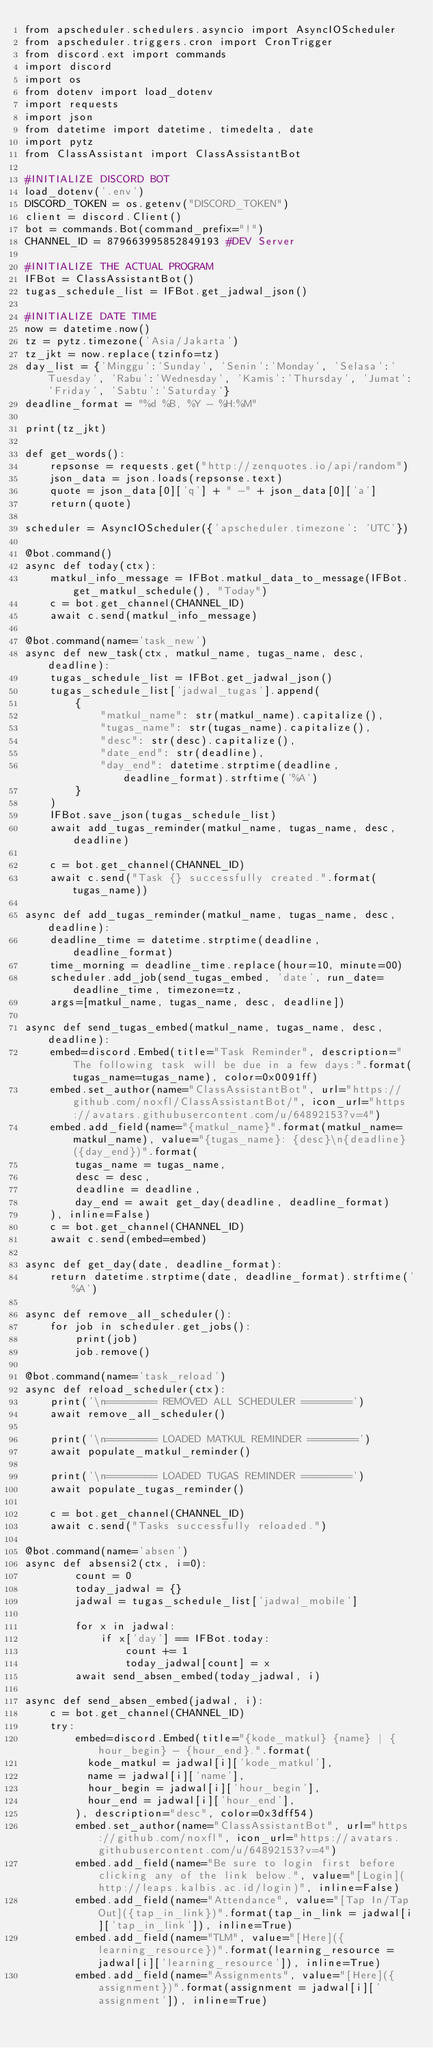<code> <loc_0><loc_0><loc_500><loc_500><_Python_>from apscheduler.schedulers.asyncio import AsyncIOScheduler
from apscheduler.triggers.cron import CronTrigger
from discord.ext import commands
import discord
import os
from dotenv import load_dotenv
import requests
import json
from datetime import datetime, timedelta, date
import pytz
from ClassAssistant import ClassAssistantBot

#INITIALIZE DISCORD BOT
load_dotenv('.env')
DISCORD_TOKEN = os.getenv("DISCORD_TOKEN")
client = discord.Client()
bot = commands.Bot(command_prefix="!")
CHANNEL_ID = 879663995852849193 #DEV Server

#INITIALIZE THE ACTUAL PROGRAM
IFBot = ClassAssistantBot()
tugas_schedule_list = IFBot.get_jadwal_json()

#INITIALIZE DATE TIME
now = datetime.now()
tz = pytz.timezone('Asia/Jakarta')
tz_jkt = now.replace(tzinfo=tz)
day_list = {'Minggu':'Sunday', 'Senin':'Monday', 'Selasa':'Tuesday', 'Rabu':'Wednesday', 'Kamis':'Thursday', 'Jumat':'Friday', 'Sabtu':'Saturday'}
deadline_format = "%d %B, %Y - %H:%M"

print(tz_jkt)

def get_words():
    repsonse = requests.get("http://zenquotes.io/api/random")
    json_data = json.loads(repsonse.text)
    quote = json_data[0]['q'] + " -" + json_data[0]['a']
    return(quote)

scheduler = AsyncIOScheduler({'apscheduler.timezone': 'UTC'})

@bot.command()
async def today(ctx):
    matkul_info_message = IFBot.matkul_data_to_message(IFBot.get_matkul_schedule(), "Today")
    c = bot.get_channel(CHANNEL_ID)
    await c.send(matkul_info_message)

@bot.command(name='task_new')
async def new_task(ctx, matkul_name, tugas_name, desc, deadline):
    tugas_schedule_list = IFBot.get_jadwal_json()
    tugas_schedule_list['jadwal_tugas'].append(
        {      
            "matkul_name": str(matkul_name).capitalize(),
            "tugas_name": str(tugas_name).capitalize(),
            "desc": str(desc).capitalize(),
            "date_end": str(deadline),
            "day_end": datetime.strptime(deadline, deadline_format).strftime('%A')
        }
    )
    IFBot.save_json(tugas_schedule_list)
    await add_tugas_reminder(matkul_name, tugas_name, desc, deadline)

    c = bot.get_channel(CHANNEL_ID)
    await c.send("Task {} successfully created.".format(tugas_name))
    
async def add_tugas_reminder(matkul_name, tugas_name, desc, deadline):
    deadline_time = datetime.strptime(deadline, deadline_format)
    time_morning = deadline_time.replace(hour=10, minute=00)
    scheduler.add_job(send_tugas_embed, 'date', run_date=deadline_time, timezone=tz, 
    args=[matkul_name, tugas_name, desc, deadline])

async def send_tugas_embed(matkul_name, tugas_name, desc, deadline):
    embed=discord.Embed(title="Task Reminder", description="The following task will be due in a few days:".format(tugas_name=tugas_name), color=0x0091ff)
    embed.set_author(name="ClassAssistantBot", url="https://github.com/noxfl/ClassAssistantBot/", icon_url="https://avatars.githubusercontent.com/u/64892153?v=4")
    embed.add_field(name="{matkul_name}".format(matkul_name=matkul_name), value="{tugas_name}: {desc}\n{deadline} ({day_end})".format(
        tugas_name = tugas_name,
        desc = desc,
        deadline = deadline,
        day_end = await get_day(deadline, deadline_format)
    ), inline=False)
    c = bot.get_channel(CHANNEL_ID)
    await c.send(embed=embed)

async def get_day(date, deadline_format):
    return datetime.strptime(date, deadline_format).strftime('%A')

async def remove_all_scheduler():
    for job in scheduler.get_jobs():
        print(job)
        job.remove()

@bot.command(name='task_reload')
async def reload_scheduler(ctx):
    print('\n======== REMOVED ALL SCHEDULER ========')
    await remove_all_scheduler()
    
    print('\n======== LOADED MATKUL REMINDER ========')
    await populate_matkul_reminder()
    
    print('\n======== LOADED TUGAS REMINDER ========')
    await populate_tugas_reminder()
    
    c = bot.get_channel(CHANNEL_ID)
    await c.send("Tasks successfully reloaded.")
    
@bot.command(name='absen')
async def absensi2(ctx, i=0):
        count = 0
        today_jadwal = {}
        jadwal = tugas_schedule_list['jadwal_mobile']

        for x in jadwal:
            if x['day'] == IFBot.today:
                count += 1
                today_jadwal[count] = x
        await send_absen_embed(today_jadwal, i)

async def send_absen_embed(jadwal, i):
    c = bot.get_channel(CHANNEL_ID)
    try:
        embed=discord.Embed(title="{kode_matkul} {name} | {hour_begin} - {hour_end}.".format(
          kode_matkul = jadwal[i]['kode_matkul'],
          name = jadwal[i]['name'],
          hour_begin = jadwal[i]['hour_begin'],
          hour_end = jadwal[i]['hour_end'],
        ), description="desc", color=0x3dff54)
        embed.set_author(name="ClassAssistantBot", url="https://github.com/noxfl", icon_url="https://avatars.githubusercontent.com/u/64892153?v=4")
        embed.add_field(name="Be sure to login first before clicking any of the link below.", value="[Login](http://leaps.kalbis.ac.id/login)", inline=False)
        embed.add_field(name="Attendance", value="[Tap In/Tap Out]({tap_in_link})".format(tap_in_link = jadwal[i]['tap_in_link']), inline=True)
        embed.add_field(name="TLM", value="[Here]({learning_resource})".format(learning_resource = jadwal[i]['learning_resource']), inline=True)
        embed.add_field(name="Assignments", value="[Here]({assignment})".format(assignment = jadwal[i]['assignment']), inline=True)</code> 